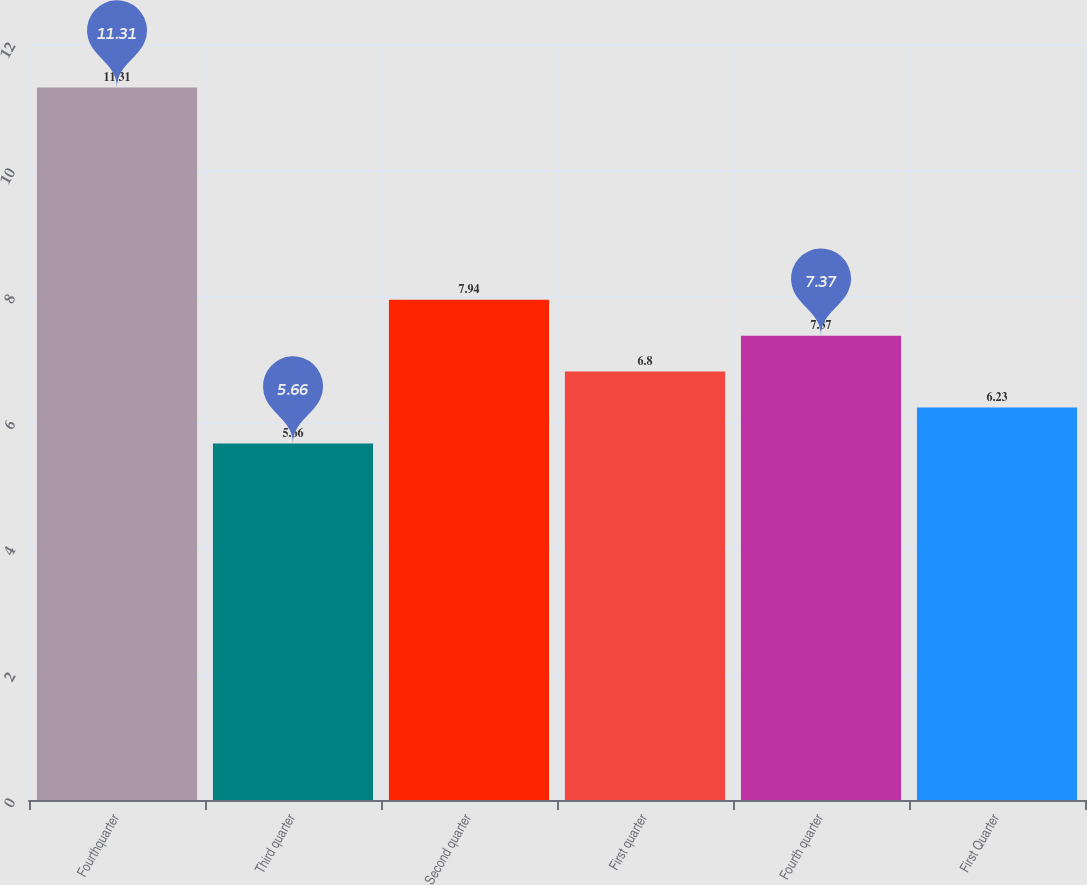Convert chart to OTSL. <chart><loc_0><loc_0><loc_500><loc_500><bar_chart><fcel>Fourthquarter<fcel>Third quarter<fcel>Second quarter<fcel>First quarter<fcel>Fourth quarter<fcel>First Quarter<nl><fcel>11.31<fcel>5.66<fcel>7.94<fcel>6.8<fcel>7.37<fcel>6.23<nl></chart> 